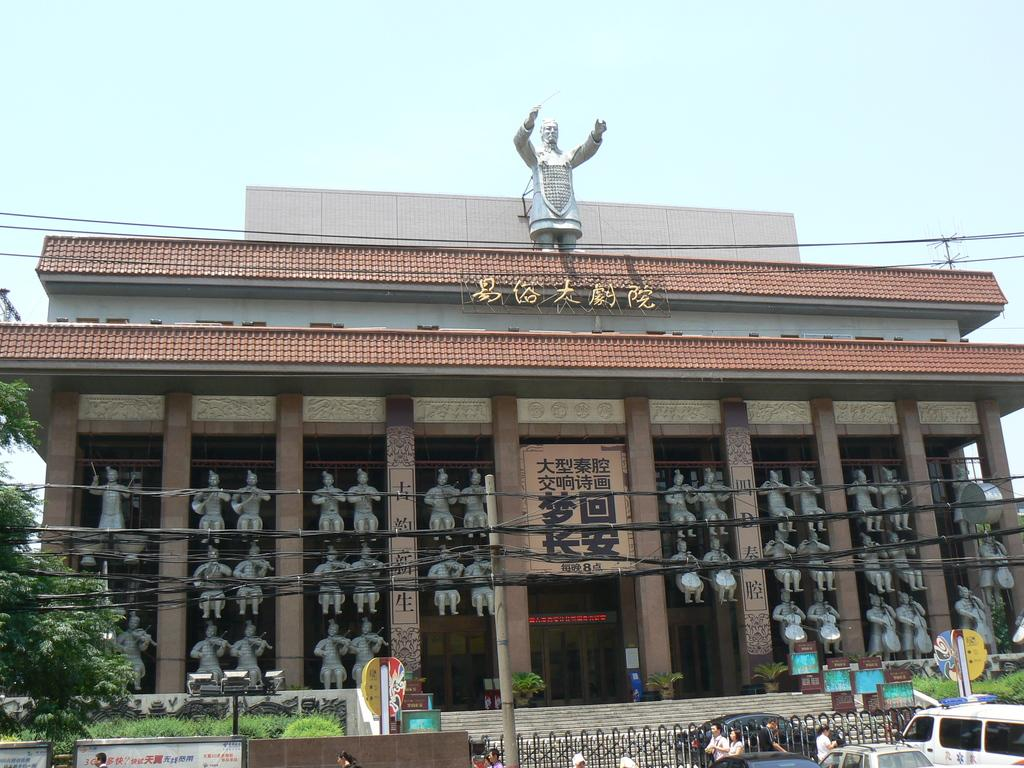What type of structure can be seen in the image? There is a building in the image. What is hanging or attached to the building? There is a banner in the image. What type of decorative or artistic elements are present in the image? There are statues in the image. What type of natural elements are present in the image? There are trees and grass in the image. Are there any living beings in the image? Yes, there are people in the image. What type of barrier or enclosure is present in the image? There is a fence in the image. What type of vehicles can be seen in the image? There are cars on the right side of the image. What is visible at the top of the image? The sky is visible at the top of the image. What type of lumber is being used to construct the building in the image? There is no information about the type of lumber used in the construction of the building in the image. How far can the person in the image see with their eye? There is no information about the person's vision or the distance they can see in the image. 